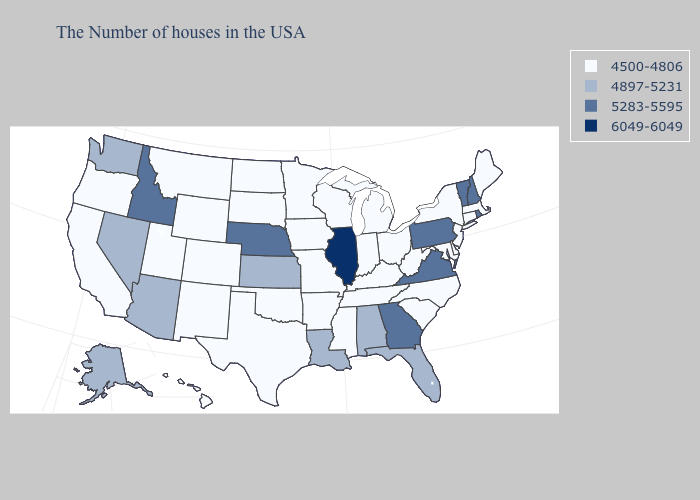Which states hav the highest value in the Northeast?
Answer briefly. Rhode Island, New Hampshire, Vermont, Pennsylvania. Name the states that have a value in the range 4897-5231?
Quick response, please. Florida, Alabama, Louisiana, Kansas, Arizona, Nevada, Washington, Alaska. Name the states that have a value in the range 6049-6049?
Be succinct. Illinois. Among the states that border West Virginia , which have the lowest value?
Keep it brief. Maryland, Ohio, Kentucky. What is the lowest value in the USA?
Answer briefly. 4500-4806. What is the value of Illinois?
Concise answer only. 6049-6049. Name the states that have a value in the range 6049-6049?
Answer briefly. Illinois. Name the states that have a value in the range 4500-4806?
Keep it brief. Maine, Massachusetts, Connecticut, New York, New Jersey, Delaware, Maryland, North Carolina, South Carolina, West Virginia, Ohio, Michigan, Kentucky, Indiana, Tennessee, Wisconsin, Mississippi, Missouri, Arkansas, Minnesota, Iowa, Oklahoma, Texas, South Dakota, North Dakota, Wyoming, Colorado, New Mexico, Utah, Montana, California, Oregon, Hawaii. Which states have the highest value in the USA?
Be succinct. Illinois. Name the states that have a value in the range 5283-5595?
Concise answer only. Rhode Island, New Hampshire, Vermont, Pennsylvania, Virginia, Georgia, Nebraska, Idaho. What is the highest value in the West ?
Quick response, please. 5283-5595. What is the value of Michigan?
Concise answer only. 4500-4806. Which states hav the highest value in the West?
Give a very brief answer. Idaho. Name the states that have a value in the range 4500-4806?
Answer briefly. Maine, Massachusetts, Connecticut, New York, New Jersey, Delaware, Maryland, North Carolina, South Carolina, West Virginia, Ohio, Michigan, Kentucky, Indiana, Tennessee, Wisconsin, Mississippi, Missouri, Arkansas, Minnesota, Iowa, Oklahoma, Texas, South Dakota, North Dakota, Wyoming, Colorado, New Mexico, Utah, Montana, California, Oregon, Hawaii. Name the states that have a value in the range 4897-5231?
Be succinct. Florida, Alabama, Louisiana, Kansas, Arizona, Nevada, Washington, Alaska. 